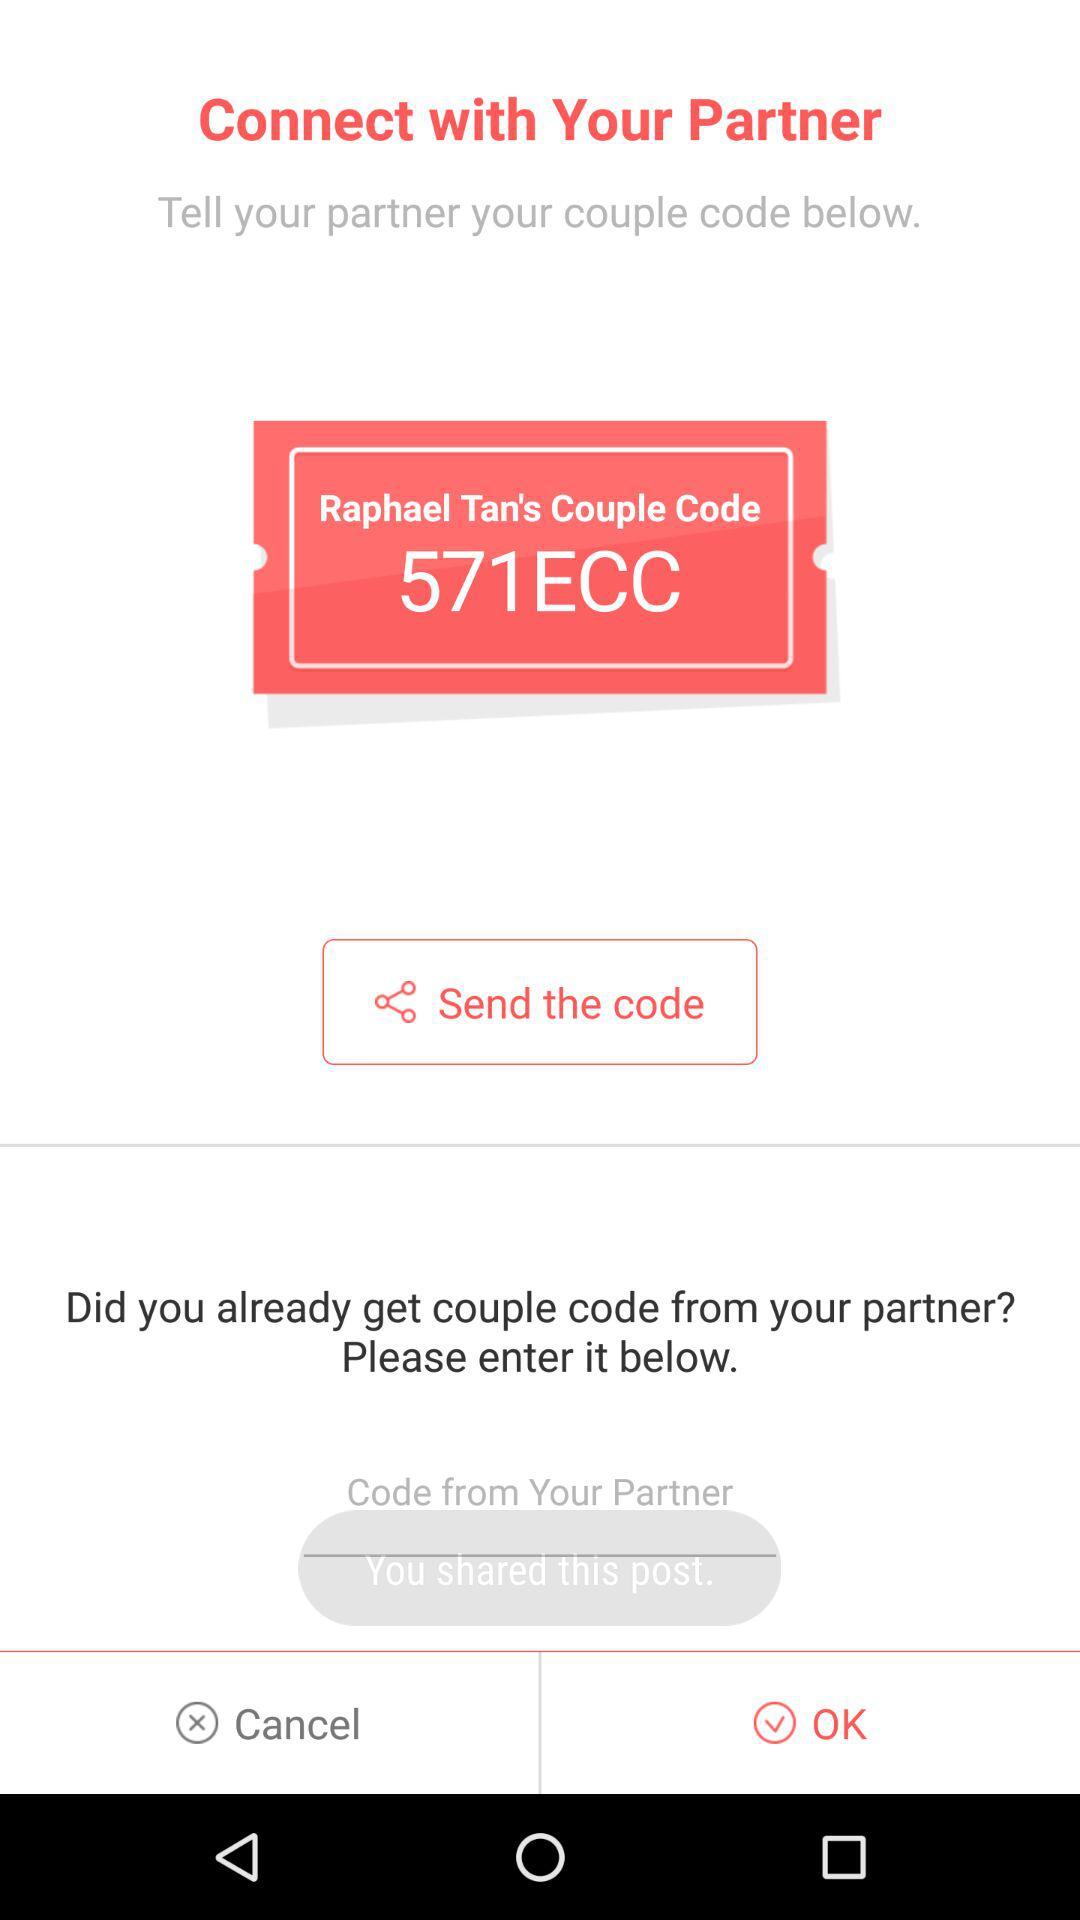What is the "571ECC"? The "571ECC" is Raphael Tan's couple code. 